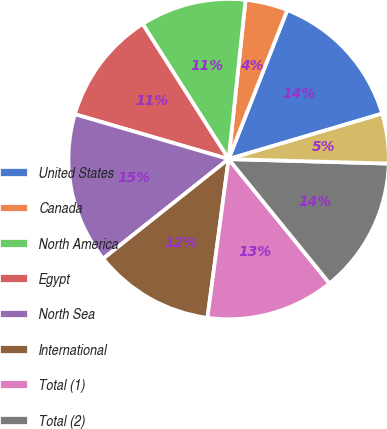<chart> <loc_0><loc_0><loc_500><loc_500><pie_chart><fcel>United States<fcel>Canada<fcel>North America<fcel>Egypt<fcel>North Sea<fcel>International<fcel>Total (1)<fcel>Total (2)<fcel>Total<nl><fcel>14.45%<fcel>4.28%<fcel>10.71%<fcel>11.46%<fcel>15.2%<fcel>12.21%<fcel>12.96%<fcel>13.7%<fcel>5.03%<nl></chart> 